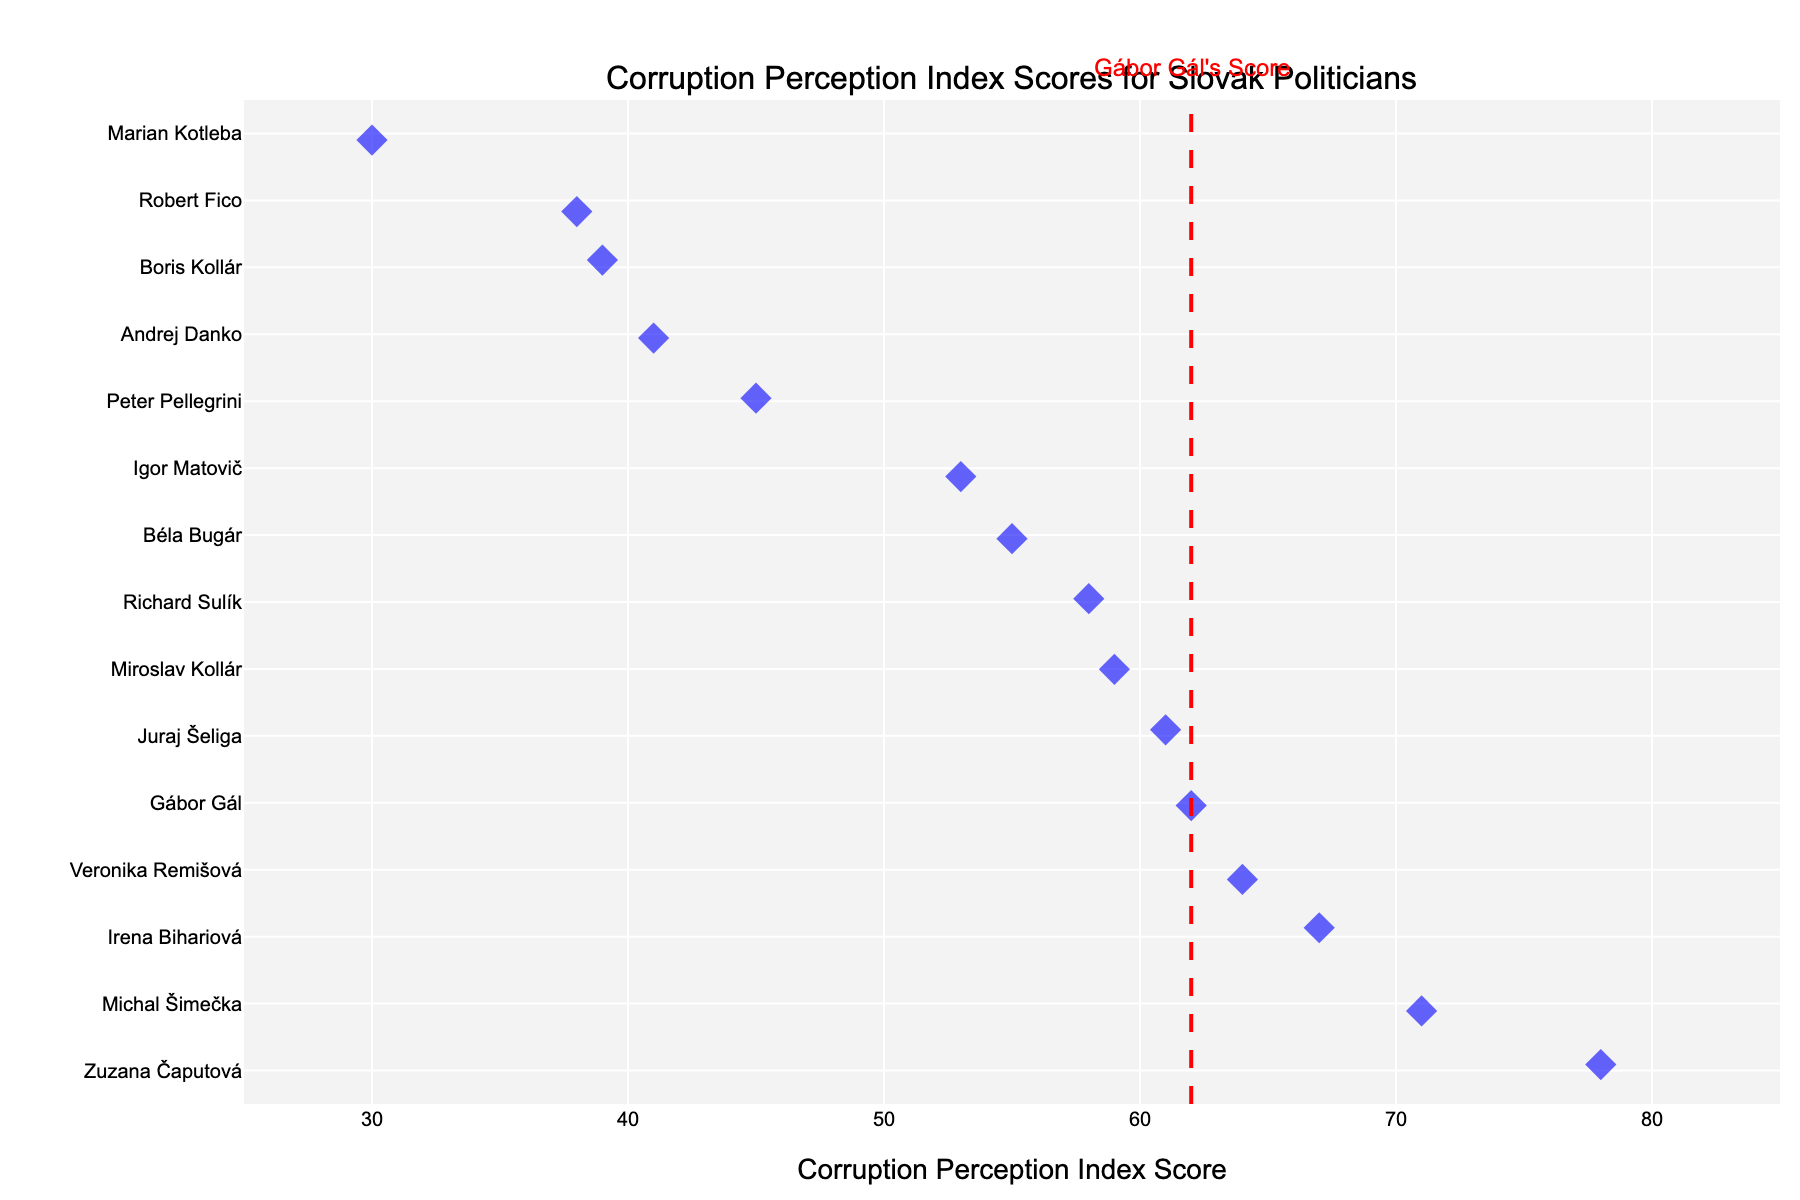What is the Corruption Perception Index Score of Gábor Gál? Gábor Gál's score is indicated by a red vertical line on the plot. The score aligned with this line is labeled Gábor Gál's Score.
Answer: 62 How does Gábor Gál's score compare to the highest score in the plot? By observing the positions of the points and their labels, the highest score belongs to Zuzana Čaputová with 78. Gábor Gál's score is 62. Therefore, Gábor Gál's score is lower than the highest score.
Answer: Lower Which Slovak politician has the lowest Corruption Perception Index Score, and what is the score? The plot shows scores from the highest to the lowest, with Marian Kotleba having the lowest score located at the bottom at 30.
Answer: Marian Kotleba - 30 How many politicians have a higher Corruption Perception Index Score than Gábor Gál? By counting the politicians' scores that are higher than 62, the scores that meet this criterion are Zuzana Čaputová (78), Irena Bihariová (67), Michal Šimečka (71), and Veronika Remišová (64). Therefore, four politicians have a score higher than Gábor Gál.
Answer: 4 What is the average Corruption Perception Index Score of the politicians listed? To find the average, sum all the scores and divide by the number of scores: (62 + 38 + 53 + 78 + 45 + 41 + 55 + 39 + 30 + 58 + 64 + 59 + 61 + 67 + 71) / 15 = 57.4.
Answer: 57.4 What is the difference between the highest and the lowest Corruption Perception Index Scores? Subtract the lowest score (Marian Kotleba - 30) from the highest score (Zuzana Čaputová - 78): 78 - 30 = 48.
Answer: 48 Who are the politicians with scores close to Gábor Gál's score? By examining the plot for scores near 62, Juraj Šeliga (61) and Veronika Remišová (64) are the closest.
Answer: Juraj Šeliga and Veronika Remišová What is the median Corruption Perception Index Score of the politicians? To find the median, arrange the scores in ascending order and find the middle value. The ordered scores are: 30, 38, 39, 41, 45, 53, 55, 58, 59, 61, 62, 64, 67, 71, 78. The median (8th value) is 58.
Answer: 58 